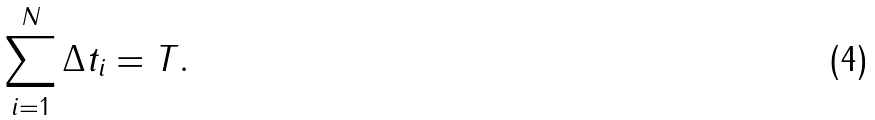<formula> <loc_0><loc_0><loc_500><loc_500>\sum _ { i = 1 } ^ { N } \Delta t _ { i } = T .</formula> 